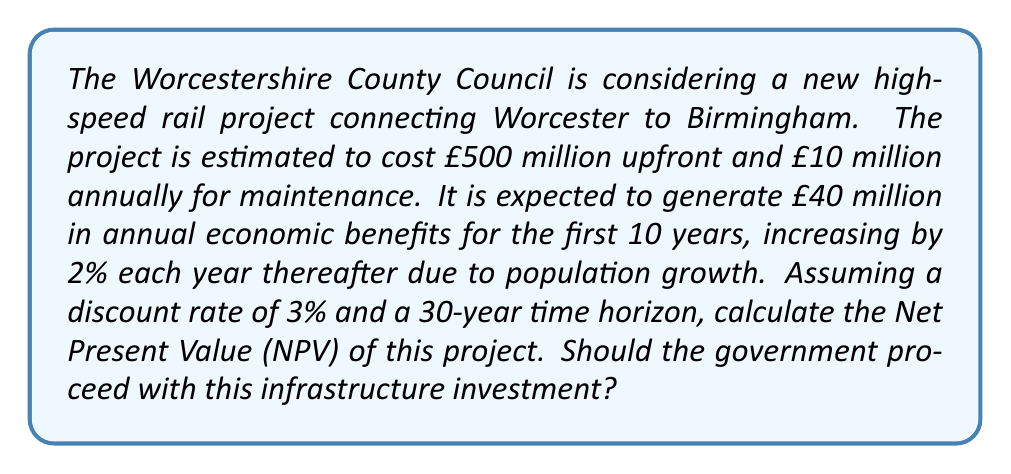What is the answer to this math problem? To calculate the NPV, we need to determine the present value of all costs and benefits over the 30-year period. Let's break this down step-by-step:

1. Initial cost: £500 million (occurs at t=0)

2. Annual maintenance cost: £10 million (constant for all 30 years)
Present Value of maintenance costs:
$$PV_{maintenance} = 10 \times \sum_{t=1}^{30} \frac{1}{(1.03)^t}$$

3. Annual benefits:
- Years 1-10: £40 million per year
- Years 11-30: Increasing by 2% each year, starting from £40.8 million in year 11

Present Value of benefits:
$$PV_{benefits} = \sum_{t=1}^{10} \frac{40}{(1.03)^t} + \sum_{t=11}^{30} \frac{40.8 \times (1.02)^{t-11}}{(1.03)^t}$$

4. Calculate NPV:
$$NPV = PV_{benefits} - PV_{maintenance} - 500$$

Using a financial calculator or spreadsheet to compute these sums:

$$PV_{maintenance} \approx 232.81 \text{ million}$$
$$PV_{benefits} \approx 897.65 \text{ million}$$

Therefore:
$$NPV = 897.65 - 232.81 - 500 = 164.84 \text{ million}$$

Since the NPV is positive, the project is economically viable and the government should proceed with the investment.
Answer: £164.84 million; Yes, proceed with the project. 